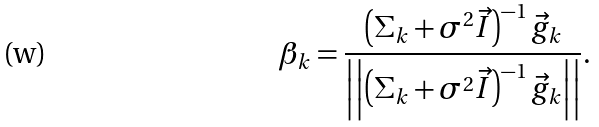<formula> <loc_0><loc_0><loc_500><loc_500>\beta _ { k } = \frac { \left ( \Sigma _ { k } + \sigma ^ { 2 } \vec { I } \right ) ^ { - 1 } \vec { g } _ { k } } { \left | \left | { \left ( \Sigma _ { k } + \sigma ^ { 2 } \vec { I } \right ) ^ { - 1 } \vec { g } _ { k } } \right | \right | } .</formula> 